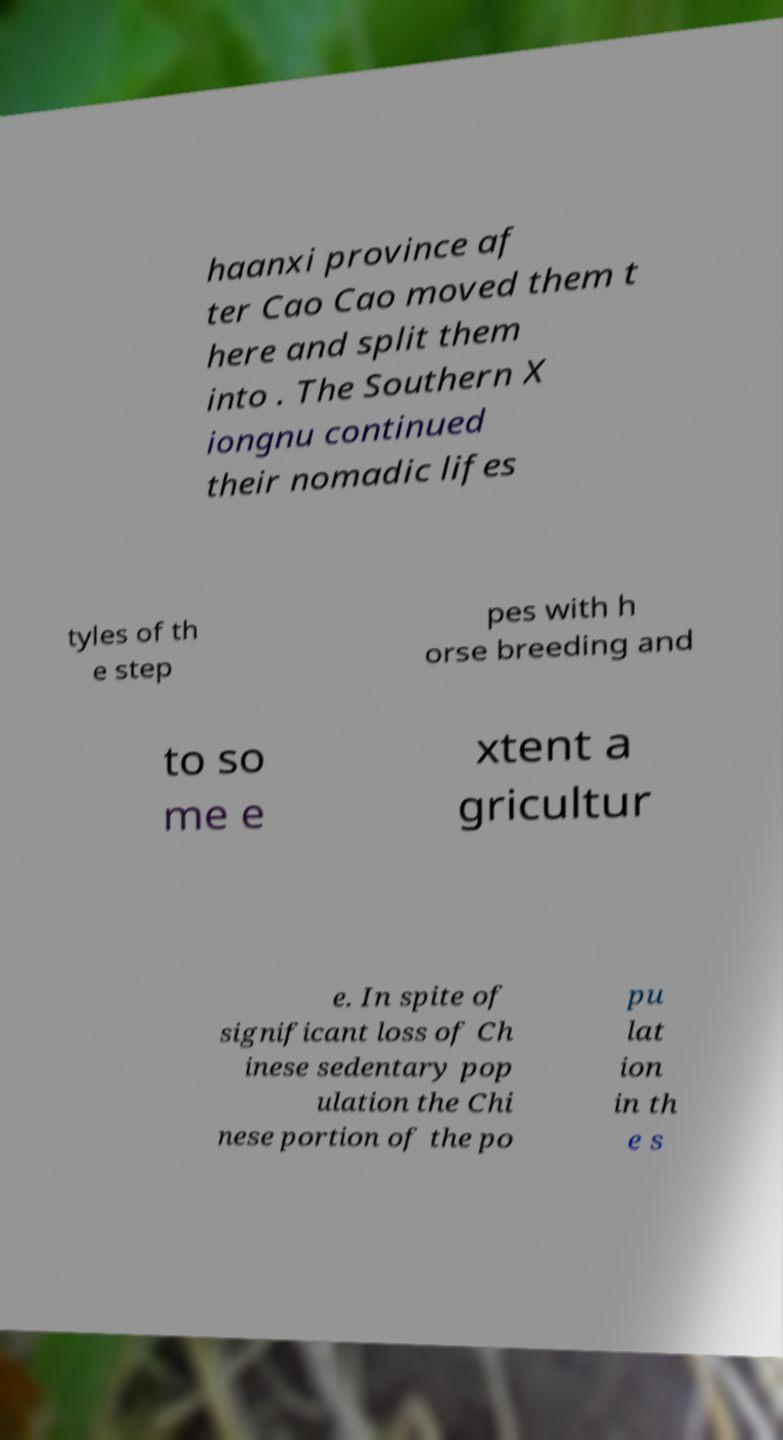For documentation purposes, I need the text within this image transcribed. Could you provide that? haanxi province af ter Cao Cao moved them t here and split them into . The Southern X iongnu continued their nomadic lifes tyles of th e step pes with h orse breeding and to so me e xtent a gricultur e. In spite of significant loss of Ch inese sedentary pop ulation the Chi nese portion of the po pu lat ion in th e s 